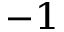Convert formula to latex. <formula><loc_0><loc_0><loc_500><loc_500>^ { - 1 }</formula> 